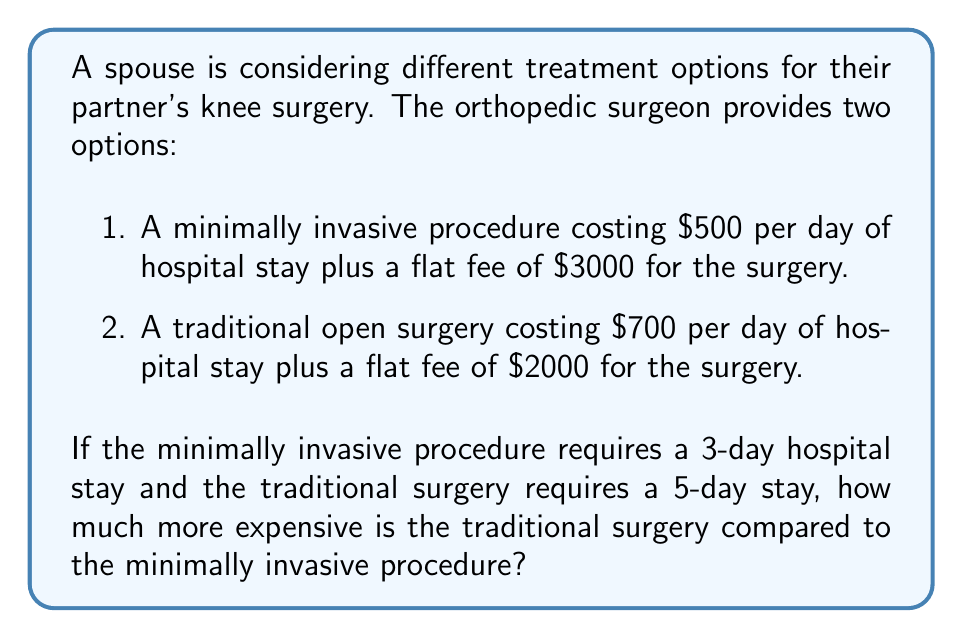Solve this math problem. Let's approach this step-by-step:

1. Calculate the cost of the minimally invasive procedure:
   - Daily cost: $500 × 3 days = $1500
   - Flat fee: $3000
   - Total cost: $1500 + $3000 = $4500

   We can express this as an equation:
   $$C_m = 500d + 3000$$
   where $C_m$ is the total cost and $d$ is the number of days.

2. Calculate the cost of the traditional surgery:
   - Daily cost: $700 × 5 days = $3500
   - Flat fee: $2000
   - Total cost: $3500 + $2000 = $5500

   We can express this as an equation:
   $$C_t = 700d + 2000$$
   where $C_t$ is the total cost and $d$ is the number of days.

3. Calculate the difference in cost:
   $5500 - $4500 = $1000

Therefore, the traditional surgery is $1000 more expensive than the minimally invasive procedure.
Answer: $1000 